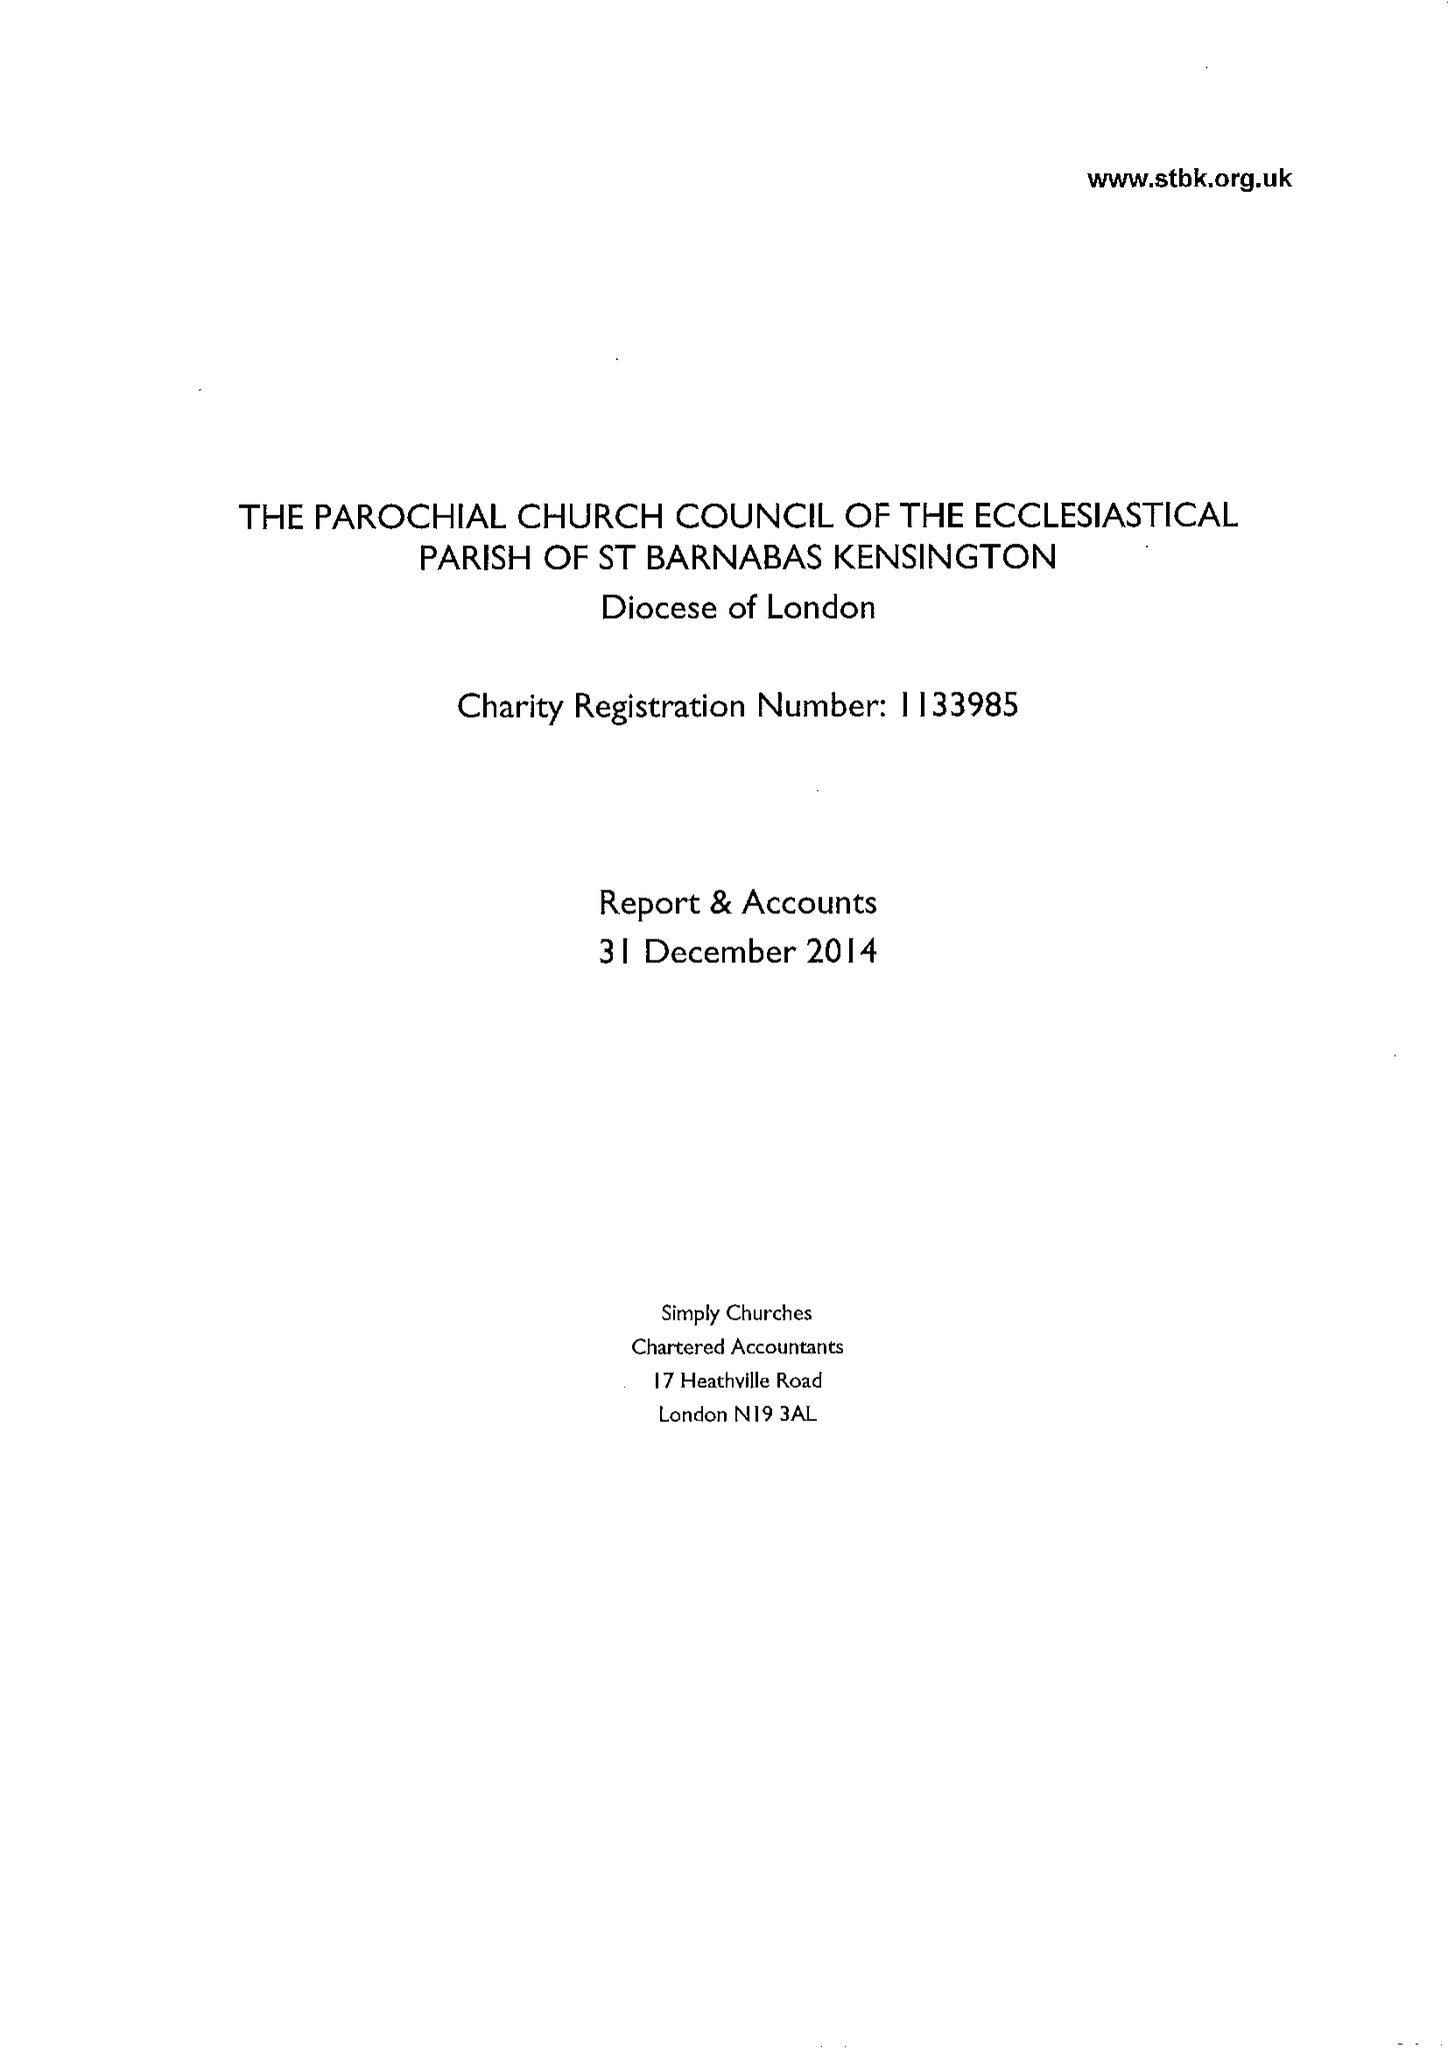What is the value for the address__postcode?
Answer the question using a single word or phrase. W14 8LH 